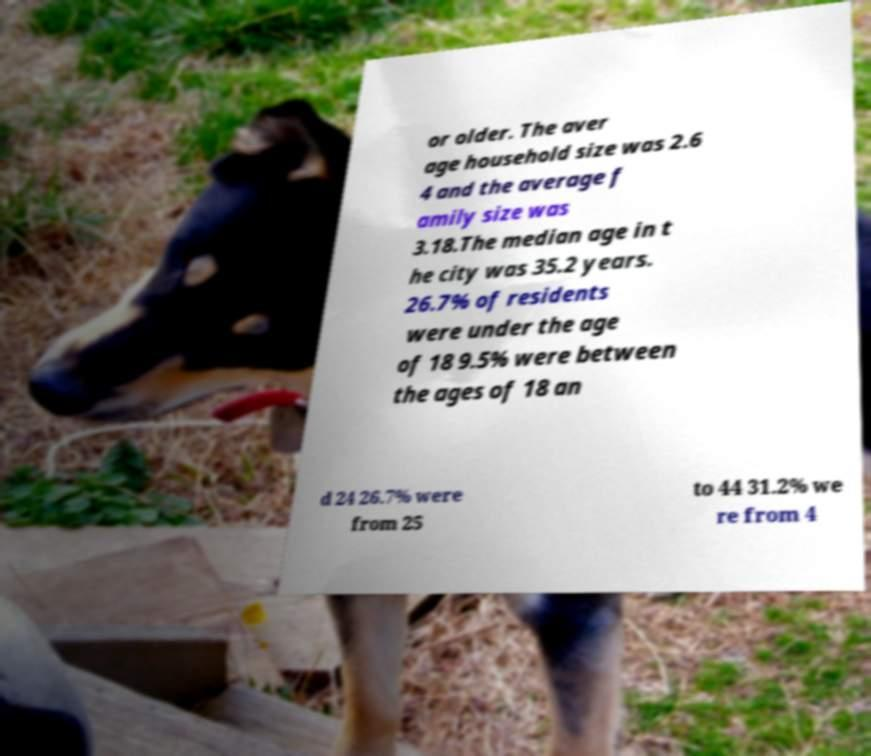Please identify and transcribe the text found in this image. or older. The aver age household size was 2.6 4 and the average f amily size was 3.18.The median age in t he city was 35.2 years. 26.7% of residents were under the age of 18 9.5% were between the ages of 18 an d 24 26.7% were from 25 to 44 31.2% we re from 4 